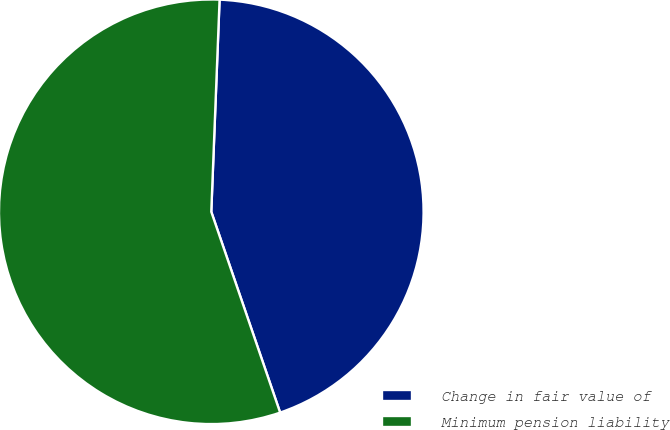Convert chart to OTSL. <chart><loc_0><loc_0><loc_500><loc_500><pie_chart><fcel>Change in fair value of<fcel>Minimum pension liability<nl><fcel>44.12%<fcel>55.88%<nl></chart> 